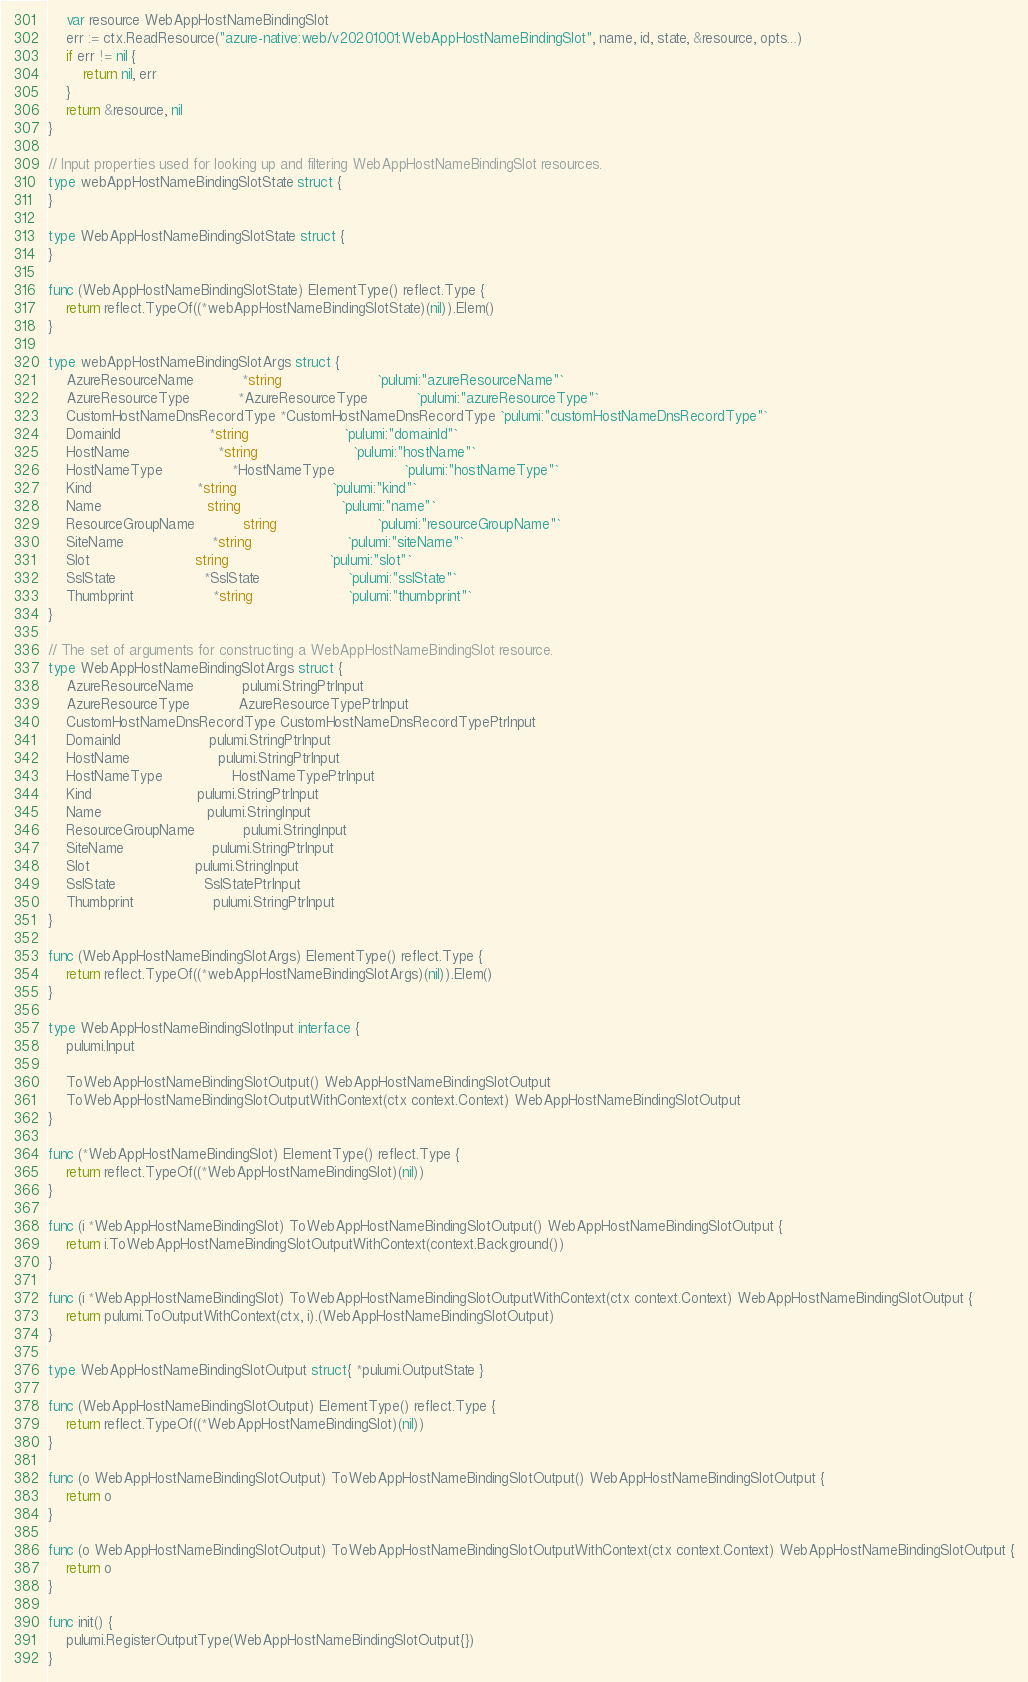Convert code to text. <code><loc_0><loc_0><loc_500><loc_500><_Go_>	var resource WebAppHostNameBindingSlot
	err := ctx.ReadResource("azure-native:web/v20201001:WebAppHostNameBindingSlot", name, id, state, &resource, opts...)
	if err != nil {
		return nil, err
	}
	return &resource, nil
}

// Input properties used for looking up and filtering WebAppHostNameBindingSlot resources.
type webAppHostNameBindingSlotState struct {
}

type WebAppHostNameBindingSlotState struct {
}

func (WebAppHostNameBindingSlotState) ElementType() reflect.Type {
	return reflect.TypeOf((*webAppHostNameBindingSlotState)(nil)).Elem()
}

type webAppHostNameBindingSlotArgs struct {
	AzureResourceName           *string                      `pulumi:"azureResourceName"`
	AzureResourceType           *AzureResourceType           `pulumi:"azureResourceType"`
	CustomHostNameDnsRecordType *CustomHostNameDnsRecordType `pulumi:"customHostNameDnsRecordType"`
	DomainId                    *string                      `pulumi:"domainId"`
	HostName                    *string                      `pulumi:"hostName"`
	HostNameType                *HostNameType                `pulumi:"hostNameType"`
	Kind                        *string                      `pulumi:"kind"`
	Name                        string                       `pulumi:"name"`
	ResourceGroupName           string                       `pulumi:"resourceGroupName"`
	SiteName                    *string                      `pulumi:"siteName"`
	Slot                        string                       `pulumi:"slot"`
	SslState                    *SslState                    `pulumi:"sslState"`
	Thumbprint                  *string                      `pulumi:"thumbprint"`
}

// The set of arguments for constructing a WebAppHostNameBindingSlot resource.
type WebAppHostNameBindingSlotArgs struct {
	AzureResourceName           pulumi.StringPtrInput
	AzureResourceType           AzureResourceTypePtrInput
	CustomHostNameDnsRecordType CustomHostNameDnsRecordTypePtrInput
	DomainId                    pulumi.StringPtrInput
	HostName                    pulumi.StringPtrInput
	HostNameType                HostNameTypePtrInput
	Kind                        pulumi.StringPtrInput
	Name                        pulumi.StringInput
	ResourceGroupName           pulumi.StringInput
	SiteName                    pulumi.StringPtrInput
	Slot                        pulumi.StringInput
	SslState                    SslStatePtrInput
	Thumbprint                  pulumi.StringPtrInput
}

func (WebAppHostNameBindingSlotArgs) ElementType() reflect.Type {
	return reflect.TypeOf((*webAppHostNameBindingSlotArgs)(nil)).Elem()
}

type WebAppHostNameBindingSlotInput interface {
	pulumi.Input

	ToWebAppHostNameBindingSlotOutput() WebAppHostNameBindingSlotOutput
	ToWebAppHostNameBindingSlotOutputWithContext(ctx context.Context) WebAppHostNameBindingSlotOutput
}

func (*WebAppHostNameBindingSlot) ElementType() reflect.Type {
	return reflect.TypeOf((*WebAppHostNameBindingSlot)(nil))
}

func (i *WebAppHostNameBindingSlot) ToWebAppHostNameBindingSlotOutput() WebAppHostNameBindingSlotOutput {
	return i.ToWebAppHostNameBindingSlotOutputWithContext(context.Background())
}

func (i *WebAppHostNameBindingSlot) ToWebAppHostNameBindingSlotOutputWithContext(ctx context.Context) WebAppHostNameBindingSlotOutput {
	return pulumi.ToOutputWithContext(ctx, i).(WebAppHostNameBindingSlotOutput)
}

type WebAppHostNameBindingSlotOutput struct{ *pulumi.OutputState }

func (WebAppHostNameBindingSlotOutput) ElementType() reflect.Type {
	return reflect.TypeOf((*WebAppHostNameBindingSlot)(nil))
}

func (o WebAppHostNameBindingSlotOutput) ToWebAppHostNameBindingSlotOutput() WebAppHostNameBindingSlotOutput {
	return o
}

func (o WebAppHostNameBindingSlotOutput) ToWebAppHostNameBindingSlotOutputWithContext(ctx context.Context) WebAppHostNameBindingSlotOutput {
	return o
}

func init() {
	pulumi.RegisterOutputType(WebAppHostNameBindingSlotOutput{})
}
</code> 